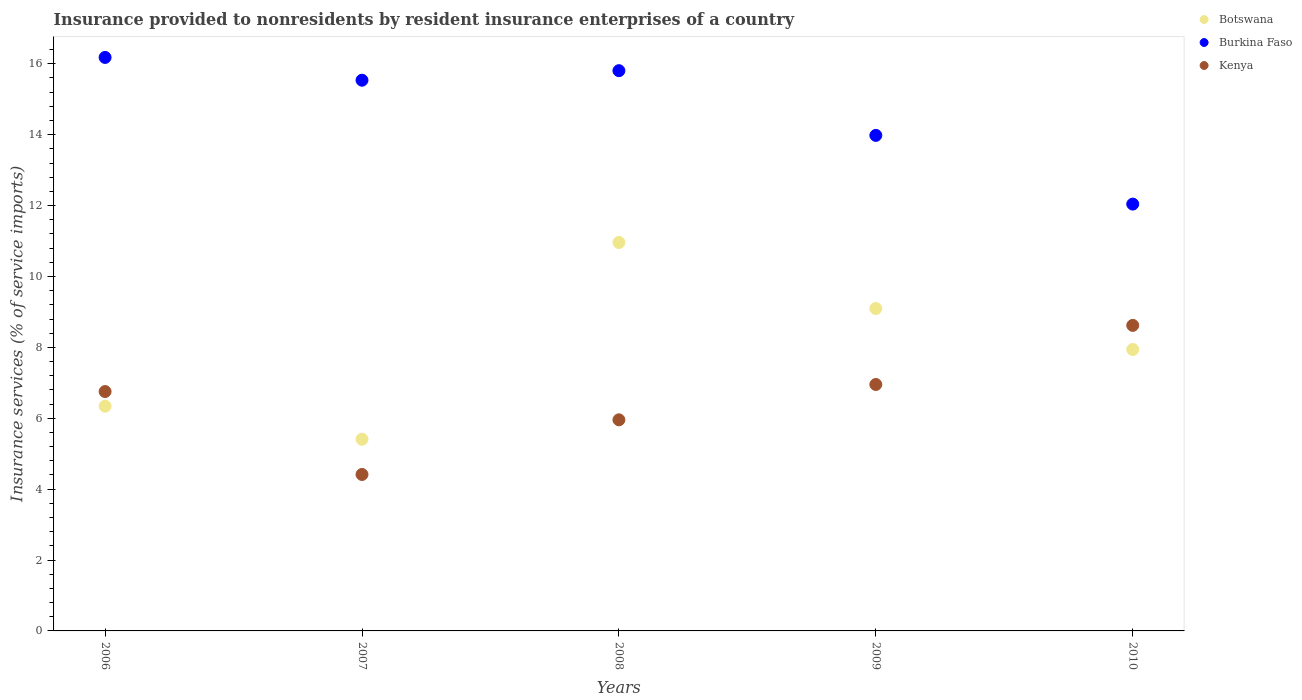How many different coloured dotlines are there?
Ensure brevity in your answer.  3. What is the insurance provided to nonresidents in Botswana in 2008?
Give a very brief answer. 10.96. Across all years, what is the maximum insurance provided to nonresidents in Burkina Faso?
Make the answer very short. 16.18. Across all years, what is the minimum insurance provided to nonresidents in Burkina Faso?
Provide a short and direct response. 12.04. In which year was the insurance provided to nonresidents in Burkina Faso maximum?
Keep it short and to the point. 2006. What is the total insurance provided to nonresidents in Botswana in the graph?
Provide a succinct answer. 39.74. What is the difference between the insurance provided to nonresidents in Botswana in 2006 and that in 2010?
Provide a short and direct response. -1.6. What is the difference between the insurance provided to nonresidents in Botswana in 2006 and the insurance provided to nonresidents in Burkina Faso in 2008?
Offer a very short reply. -9.47. What is the average insurance provided to nonresidents in Kenya per year?
Ensure brevity in your answer.  6.54. In the year 2008, what is the difference between the insurance provided to nonresidents in Botswana and insurance provided to nonresidents in Kenya?
Ensure brevity in your answer.  5. What is the ratio of the insurance provided to nonresidents in Burkina Faso in 2007 to that in 2009?
Offer a terse response. 1.11. Is the insurance provided to nonresidents in Kenya in 2009 less than that in 2010?
Your response must be concise. Yes. Is the difference between the insurance provided to nonresidents in Botswana in 2006 and 2009 greater than the difference between the insurance provided to nonresidents in Kenya in 2006 and 2009?
Ensure brevity in your answer.  No. What is the difference between the highest and the second highest insurance provided to nonresidents in Kenya?
Provide a succinct answer. 1.67. What is the difference between the highest and the lowest insurance provided to nonresidents in Kenya?
Offer a very short reply. 4.21. Is it the case that in every year, the sum of the insurance provided to nonresidents in Kenya and insurance provided to nonresidents in Botswana  is greater than the insurance provided to nonresidents in Burkina Faso?
Provide a succinct answer. No. Is the insurance provided to nonresidents in Kenya strictly greater than the insurance provided to nonresidents in Botswana over the years?
Keep it short and to the point. No. How many years are there in the graph?
Your response must be concise. 5. What is the difference between two consecutive major ticks on the Y-axis?
Keep it short and to the point. 2. Does the graph contain any zero values?
Make the answer very short. No. How are the legend labels stacked?
Your answer should be very brief. Vertical. What is the title of the graph?
Your answer should be very brief. Insurance provided to nonresidents by resident insurance enterprises of a country. Does "Libya" appear as one of the legend labels in the graph?
Your response must be concise. No. What is the label or title of the Y-axis?
Your answer should be very brief. Insurance services (% of service imports). What is the Insurance services (% of service imports) in Botswana in 2006?
Provide a succinct answer. 6.34. What is the Insurance services (% of service imports) of Burkina Faso in 2006?
Keep it short and to the point. 16.18. What is the Insurance services (% of service imports) of Kenya in 2006?
Provide a succinct answer. 6.75. What is the Insurance services (% of service imports) of Botswana in 2007?
Ensure brevity in your answer.  5.41. What is the Insurance services (% of service imports) of Burkina Faso in 2007?
Provide a succinct answer. 15.54. What is the Insurance services (% of service imports) in Kenya in 2007?
Offer a very short reply. 4.41. What is the Insurance services (% of service imports) of Botswana in 2008?
Make the answer very short. 10.96. What is the Insurance services (% of service imports) of Burkina Faso in 2008?
Give a very brief answer. 15.81. What is the Insurance services (% of service imports) in Kenya in 2008?
Provide a short and direct response. 5.96. What is the Insurance services (% of service imports) in Botswana in 2009?
Provide a short and direct response. 9.1. What is the Insurance services (% of service imports) in Burkina Faso in 2009?
Make the answer very short. 13.98. What is the Insurance services (% of service imports) of Kenya in 2009?
Your answer should be very brief. 6.95. What is the Insurance services (% of service imports) in Botswana in 2010?
Offer a very short reply. 7.94. What is the Insurance services (% of service imports) of Burkina Faso in 2010?
Your answer should be compact. 12.04. What is the Insurance services (% of service imports) of Kenya in 2010?
Give a very brief answer. 8.62. Across all years, what is the maximum Insurance services (% of service imports) of Botswana?
Provide a succinct answer. 10.96. Across all years, what is the maximum Insurance services (% of service imports) of Burkina Faso?
Offer a terse response. 16.18. Across all years, what is the maximum Insurance services (% of service imports) of Kenya?
Your answer should be compact. 8.62. Across all years, what is the minimum Insurance services (% of service imports) of Botswana?
Your answer should be very brief. 5.41. Across all years, what is the minimum Insurance services (% of service imports) of Burkina Faso?
Provide a short and direct response. 12.04. Across all years, what is the minimum Insurance services (% of service imports) of Kenya?
Keep it short and to the point. 4.41. What is the total Insurance services (% of service imports) of Botswana in the graph?
Your answer should be very brief. 39.74. What is the total Insurance services (% of service imports) of Burkina Faso in the graph?
Your response must be concise. 73.55. What is the total Insurance services (% of service imports) in Kenya in the graph?
Your answer should be very brief. 32.7. What is the difference between the Insurance services (% of service imports) of Botswana in 2006 and that in 2007?
Provide a short and direct response. 0.93. What is the difference between the Insurance services (% of service imports) in Burkina Faso in 2006 and that in 2007?
Offer a terse response. 0.64. What is the difference between the Insurance services (% of service imports) of Kenya in 2006 and that in 2007?
Give a very brief answer. 2.34. What is the difference between the Insurance services (% of service imports) in Botswana in 2006 and that in 2008?
Provide a succinct answer. -4.62. What is the difference between the Insurance services (% of service imports) of Burkina Faso in 2006 and that in 2008?
Your response must be concise. 0.37. What is the difference between the Insurance services (% of service imports) of Kenya in 2006 and that in 2008?
Keep it short and to the point. 0.8. What is the difference between the Insurance services (% of service imports) in Botswana in 2006 and that in 2009?
Make the answer very short. -2.76. What is the difference between the Insurance services (% of service imports) in Burkina Faso in 2006 and that in 2009?
Provide a short and direct response. 2.2. What is the difference between the Insurance services (% of service imports) in Kenya in 2006 and that in 2009?
Ensure brevity in your answer.  -0.2. What is the difference between the Insurance services (% of service imports) in Botswana in 2006 and that in 2010?
Offer a very short reply. -1.6. What is the difference between the Insurance services (% of service imports) of Burkina Faso in 2006 and that in 2010?
Offer a terse response. 4.14. What is the difference between the Insurance services (% of service imports) in Kenya in 2006 and that in 2010?
Keep it short and to the point. -1.87. What is the difference between the Insurance services (% of service imports) in Botswana in 2007 and that in 2008?
Offer a very short reply. -5.55. What is the difference between the Insurance services (% of service imports) in Burkina Faso in 2007 and that in 2008?
Your response must be concise. -0.27. What is the difference between the Insurance services (% of service imports) of Kenya in 2007 and that in 2008?
Provide a succinct answer. -1.54. What is the difference between the Insurance services (% of service imports) in Botswana in 2007 and that in 2009?
Your answer should be very brief. -3.69. What is the difference between the Insurance services (% of service imports) in Burkina Faso in 2007 and that in 2009?
Provide a succinct answer. 1.56. What is the difference between the Insurance services (% of service imports) of Kenya in 2007 and that in 2009?
Keep it short and to the point. -2.54. What is the difference between the Insurance services (% of service imports) in Botswana in 2007 and that in 2010?
Keep it short and to the point. -2.53. What is the difference between the Insurance services (% of service imports) in Burkina Faso in 2007 and that in 2010?
Your response must be concise. 3.5. What is the difference between the Insurance services (% of service imports) of Kenya in 2007 and that in 2010?
Ensure brevity in your answer.  -4.21. What is the difference between the Insurance services (% of service imports) of Botswana in 2008 and that in 2009?
Your answer should be compact. 1.86. What is the difference between the Insurance services (% of service imports) of Burkina Faso in 2008 and that in 2009?
Your answer should be compact. 1.83. What is the difference between the Insurance services (% of service imports) in Kenya in 2008 and that in 2009?
Ensure brevity in your answer.  -1. What is the difference between the Insurance services (% of service imports) in Botswana in 2008 and that in 2010?
Offer a very short reply. 3.02. What is the difference between the Insurance services (% of service imports) in Burkina Faso in 2008 and that in 2010?
Provide a short and direct response. 3.76. What is the difference between the Insurance services (% of service imports) in Kenya in 2008 and that in 2010?
Offer a terse response. -2.66. What is the difference between the Insurance services (% of service imports) in Botswana in 2009 and that in 2010?
Your answer should be very brief. 1.16. What is the difference between the Insurance services (% of service imports) of Burkina Faso in 2009 and that in 2010?
Ensure brevity in your answer.  1.94. What is the difference between the Insurance services (% of service imports) in Kenya in 2009 and that in 2010?
Provide a succinct answer. -1.67. What is the difference between the Insurance services (% of service imports) in Botswana in 2006 and the Insurance services (% of service imports) in Burkina Faso in 2007?
Make the answer very short. -9.2. What is the difference between the Insurance services (% of service imports) of Botswana in 2006 and the Insurance services (% of service imports) of Kenya in 2007?
Give a very brief answer. 1.93. What is the difference between the Insurance services (% of service imports) of Burkina Faso in 2006 and the Insurance services (% of service imports) of Kenya in 2007?
Give a very brief answer. 11.77. What is the difference between the Insurance services (% of service imports) in Botswana in 2006 and the Insurance services (% of service imports) in Burkina Faso in 2008?
Offer a terse response. -9.47. What is the difference between the Insurance services (% of service imports) in Botswana in 2006 and the Insurance services (% of service imports) in Kenya in 2008?
Offer a terse response. 0.38. What is the difference between the Insurance services (% of service imports) in Burkina Faso in 2006 and the Insurance services (% of service imports) in Kenya in 2008?
Make the answer very short. 10.22. What is the difference between the Insurance services (% of service imports) of Botswana in 2006 and the Insurance services (% of service imports) of Burkina Faso in 2009?
Give a very brief answer. -7.64. What is the difference between the Insurance services (% of service imports) of Botswana in 2006 and the Insurance services (% of service imports) of Kenya in 2009?
Offer a terse response. -0.61. What is the difference between the Insurance services (% of service imports) in Burkina Faso in 2006 and the Insurance services (% of service imports) in Kenya in 2009?
Keep it short and to the point. 9.23. What is the difference between the Insurance services (% of service imports) in Botswana in 2006 and the Insurance services (% of service imports) in Burkina Faso in 2010?
Provide a short and direct response. -5.7. What is the difference between the Insurance services (% of service imports) of Botswana in 2006 and the Insurance services (% of service imports) of Kenya in 2010?
Provide a short and direct response. -2.28. What is the difference between the Insurance services (% of service imports) of Burkina Faso in 2006 and the Insurance services (% of service imports) of Kenya in 2010?
Make the answer very short. 7.56. What is the difference between the Insurance services (% of service imports) in Botswana in 2007 and the Insurance services (% of service imports) in Burkina Faso in 2008?
Your response must be concise. -10.4. What is the difference between the Insurance services (% of service imports) of Botswana in 2007 and the Insurance services (% of service imports) of Kenya in 2008?
Provide a short and direct response. -0.55. What is the difference between the Insurance services (% of service imports) of Burkina Faso in 2007 and the Insurance services (% of service imports) of Kenya in 2008?
Provide a succinct answer. 9.58. What is the difference between the Insurance services (% of service imports) in Botswana in 2007 and the Insurance services (% of service imports) in Burkina Faso in 2009?
Keep it short and to the point. -8.57. What is the difference between the Insurance services (% of service imports) in Botswana in 2007 and the Insurance services (% of service imports) in Kenya in 2009?
Your answer should be very brief. -1.54. What is the difference between the Insurance services (% of service imports) of Burkina Faso in 2007 and the Insurance services (% of service imports) of Kenya in 2009?
Ensure brevity in your answer.  8.58. What is the difference between the Insurance services (% of service imports) in Botswana in 2007 and the Insurance services (% of service imports) in Burkina Faso in 2010?
Your answer should be very brief. -6.63. What is the difference between the Insurance services (% of service imports) of Botswana in 2007 and the Insurance services (% of service imports) of Kenya in 2010?
Offer a very short reply. -3.21. What is the difference between the Insurance services (% of service imports) in Burkina Faso in 2007 and the Insurance services (% of service imports) in Kenya in 2010?
Make the answer very short. 6.92. What is the difference between the Insurance services (% of service imports) in Botswana in 2008 and the Insurance services (% of service imports) in Burkina Faso in 2009?
Offer a very short reply. -3.02. What is the difference between the Insurance services (% of service imports) in Botswana in 2008 and the Insurance services (% of service imports) in Kenya in 2009?
Your answer should be compact. 4.01. What is the difference between the Insurance services (% of service imports) in Burkina Faso in 2008 and the Insurance services (% of service imports) in Kenya in 2009?
Provide a succinct answer. 8.85. What is the difference between the Insurance services (% of service imports) in Botswana in 2008 and the Insurance services (% of service imports) in Burkina Faso in 2010?
Give a very brief answer. -1.08. What is the difference between the Insurance services (% of service imports) of Botswana in 2008 and the Insurance services (% of service imports) of Kenya in 2010?
Your answer should be very brief. 2.34. What is the difference between the Insurance services (% of service imports) in Burkina Faso in 2008 and the Insurance services (% of service imports) in Kenya in 2010?
Provide a short and direct response. 7.19. What is the difference between the Insurance services (% of service imports) of Botswana in 2009 and the Insurance services (% of service imports) of Burkina Faso in 2010?
Your response must be concise. -2.95. What is the difference between the Insurance services (% of service imports) in Botswana in 2009 and the Insurance services (% of service imports) in Kenya in 2010?
Give a very brief answer. 0.48. What is the difference between the Insurance services (% of service imports) of Burkina Faso in 2009 and the Insurance services (% of service imports) of Kenya in 2010?
Offer a terse response. 5.36. What is the average Insurance services (% of service imports) of Botswana per year?
Your response must be concise. 7.95. What is the average Insurance services (% of service imports) in Burkina Faso per year?
Your answer should be compact. 14.71. What is the average Insurance services (% of service imports) of Kenya per year?
Your answer should be compact. 6.54. In the year 2006, what is the difference between the Insurance services (% of service imports) of Botswana and Insurance services (% of service imports) of Burkina Faso?
Your answer should be very brief. -9.84. In the year 2006, what is the difference between the Insurance services (% of service imports) of Botswana and Insurance services (% of service imports) of Kenya?
Your answer should be very brief. -0.41. In the year 2006, what is the difference between the Insurance services (% of service imports) of Burkina Faso and Insurance services (% of service imports) of Kenya?
Provide a succinct answer. 9.43. In the year 2007, what is the difference between the Insurance services (% of service imports) in Botswana and Insurance services (% of service imports) in Burkina Faso?
Give a very brief answer. -10.13. In the year 2007, what is the difference between the Insurance services (% of service imports) in Burkina Faso and Insurance services (% of service imports) in Kenya?
Make the answer very short. 11.12. In the year 2008, what is the difference between the Insurance services (% of service imports) of Botswana and Insurance services (% of service imports) of Burkina Faso?
Give a very brief answer. -4.85. In the year 2008, what is the difference between the Insurance services (% of service imports) of Botswana and Insurance services (% of service imports) of Kenya?
Offer a very short reply. 5. In the year 2008, what is the difference between the Insurance services (% of service imports) of Burkina Faso and Insurance services (% of service imports) of Kenya?
Your response must be concise. 9.85. In the year 2009, what is the difference between the Insurance services (% of service imports) in Botswana and Insurance services (% of service imports) in Burkina Faso?
Your answer should be compact. -4.88. In the year 2009, what is the difference between the Insurance services (% of service imports) in Botswana and Insurance services (% of service imports) in Kenya?
Provide a succinct answer. 2.14. In the year 2009, what is the difference between the Insurance services (% of service imports) in Burkina Faso and Insurance services (% of service imports) in Kenya?
Your answer should be compact. 7.03. In the year 2010, what is the difference between the Insurance services (% of service imports) in Botswana and Insurance services (% of service imports) in Burkina Faso?
Offer a very short reply. -4.1. In the year 2010, what is the difference between the Insurance services (% of service imports) in Botswana and Insurance services (% of service imports) in Kenya?
Ensure brevity in your answer.  -0.68. In the year 2010, what is the difference between the Insurance services (% of service imports) in Burkina Faso and Insurance services (% of service imports) in Kenya?
Your answer should be very brief. 3.42. What is the ratio of the Insurance services (% of service imports) of Botswana in 2006 to that in 2007?
Give a very brief answer. 1.17. What is the ratio of the Insurance services (% of service imports) of Burkina Faso in 2006 to that in 2007?
Your answer should be very brief. 1.04. What is the ratio of the Insurance services (% of service imports) in Kenya in 2006 to that in 2007?
Provide a succinct answer. 1.53. What is the ratio of the Insurance services (% of service imports) of Botswana in 2006 to that in 2008?
Offer a terse response. 0.58. What is the ratio of the Insurance services (% of service imports) in Burkina Faso in 2006 to that in 2008?
Offer a terse response. 1.02. What is the ratio of the Insurance services (% of service imports) in Kenya in 2006 to that in 2008?
Give a very brief answer. 1.13. What is the ratio of the Insurance services (% of service imports) of Botswana in 2006 to that in 2009?
Your answer should be compact. 0.7. What is the ratio of the Insurance services (% of service imports) of Burkina Faso in 2006 to that in 2009?
Provide a succinct answer. 1.16. What is the ratio of the Insurance services (% of service imports) of Kenya in 2006 to that in 2009?
Ensure brevity in your answer.  0.97. What is the ratio of the Insurance services (% of service imports) in Botswana in 2006 to that in 2010?
Provide a short and direct response. 0.8. What is the ratio of the Insurance services (% of service imports) of Burkina Faso in 2006 to that in 2010?
Your response must be concise. 1.34. What is the ratio of the Insurance services (% of service imports) in Kenya in 2006 to that in 2010?
Offer a terse response. 0.78. What is the ratio of the Insurance services (% of service imports) of Botswana in 2007 to that in 2008?
Keep it short and to the point. 0.49. What is the ratio of the Insurance services (% of service imports) of Kenya in 2007 to that in 2008?
Keep it short and to the point. 0.74. What is the ratio of the Insurance services (% of service imports) in Botswana in 2007 to that in 2009?
Provide a succinct answer. 0.59. What is the ratio of the Insurance services (% of service imports) in Burkina Faso in 2007 to that in 2009?
Offer a terse response. 1.11. What is the ratio of the Insurance services (% of service imports) in Kenya in 2007 to that in 2009?
Ensure brevity in your answer.  0.63. What is the ratio of the Insurance services (% of service imports) of Botswana in 2007 to that in 2010?
Your answer should be compact. 0.68. What is the ratio of the Insurance services (% of service imports) in Burkina Faso in 2007 to that in 2010?
Provide a succinct answer. 1.29. What is the ratio of the Insurance services (% of service imports) of Kenya in 2007 to that in 2010?
Your answer should be compact. 0.51. What is the ratio of the Insurance services (% of service imports) in Botswana in 2008 to that in 2009?
Your answer should be very brief. 1.2. What is the ratio of the Insurance services (% of service imports) in Burkina Faso in 2008 to that in 2009?
Give a very brief answer. 1.13. What is the ratio of the Insurance services (% of service imports) of Kenya in 2008 to that in 2009?
Provide a succinct answer. 0.86. What is the ratio of the Insurance services (% of service imports) in Botswana in 2008 to that in 2010?
Make the answer very short. 1.38. What is the ratio of the Insurance services (% of service imports) of Burkina Faso in 2008 to that in 2010?
Make the answer very short. 1.31. What is the ratio of the Insurance services (% of service imports) of Kenya in 2008 to that in 2010?
Your answer should be compact. 0.69. What is the ratio of the Insurance services (% of service imports) in Botswana in 2009 to that in 2010?
Provide a succinct answer. 1.15. What is the ratio of the Insurance services (% of service imports) in Burkina Faso in 2009 to that in 2010?
Provide a short and direct response. 1.16. What is the ratio of the Insurance services (% of service imports) of Kenya in 2009 to that in 2010?
Provide a succinct answer. 0.81. What is the difference between the highest and the second highest Insurance services (% of service imports) of Botswana?
Keep it short and to the point. 1.86. What is the difference between the highest and the second highest Insurance services (% of service imports) in Burkina Faso?
Make the answer very short. 0.37. What is the difference between the highest and the second highest Insurance services (% of service imports) in Kenya?
Offer a terse response. 1.67. What is the difference between the highest and the lowest Insurance services (% of service imports) in Botswana?
Offer a very short reply. 5.55. What is the difference between the highest and the lowest Insurance services (% of service imports) in Burkina Faso?
Offer a terse response. 4.14. What is the difference between the highest and the lowest Insurance services (% of service imports) in Kenya?
Your answer should be very brief. 4.21. 